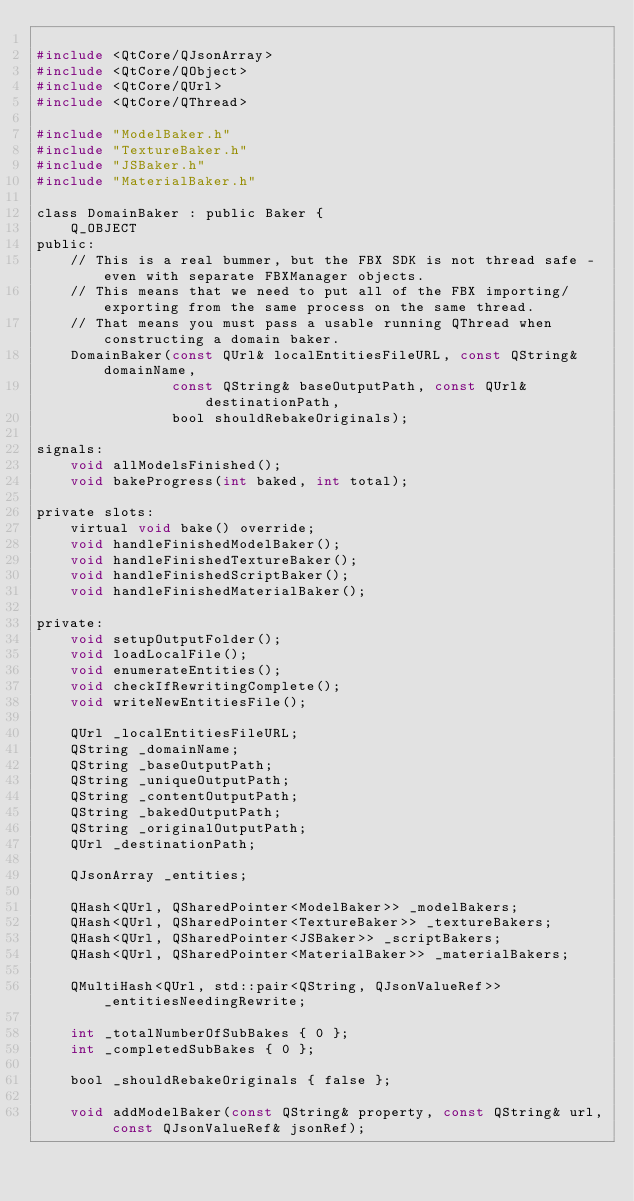<code> <loc_0><loc_0><loc_500><loc_500><_C_>
#include <QtCore/QJsonArray>
#include <QtCore/QObject>
#include <QtCore/QUrl>
#include <QtCore/QThread>

#include "ModelBaker.h"
#include "TextureBaker.h"
#include "JSBaker.h"
#include "MaterialBaker.h"

class DomainBaker : public Baker {
    Q_OBJECT
public:
    // This is a real bummer, but the FBX SDK is not thread safe - even with separate FBXManager objects.
    // This means that we need to put all of the FBX importing/exporting from the same process on the same thread.
    // That means you must pass a usable running QThread when constructing a domain baker.
    DomainBaker(const QUrl& localEntitiesFileURL, const QString& domainName,
                const QString& baseOutputPath, const QUrl& destinationPath,
                bool shouldRebakeOriginals);

signals:
    void allModelsFinished();
    void bakeProgress(int baked, int total);

private slots:
    virtual void bake() override;
    void handleFinishedModelBaker();
    void handleFinishedTextureBaker();
    void handleFinishedScriptBaker();
    void handleFinishedMaterialBaker();

private:
    void setupOutputFolder();
    void loadLocalFile();
    void enumerateEntities();
    void checkIfRewritingComplete();
    void writeNewEntitiesFile();

    QUrl _localEntitiesFileURL;
    QString _domainName;
    QString _baseOutputPath;
    QString _uniqueOutputPath;
    QString _contentOutputPath;
    QString _bakedOutputPath;
    QString _originalOutputPath;
    QUrl _destinationPath;

    QJsonArray _entities;

    QHash<QUrl, QSharedPointer<ModelBaker>> _modelBakers;
    QHash<QUrl, QSharedPointer<TextureBaker>> _textureBakers;
    QHash<QUrl, QSharedPointer<JSBaker>> _scriptBakers;
    QHash<QUrl, QSharedPointer<MaterialBaker>> _materialBakers;
    
    QMultiHash<QUrl, std::pair<QString, QJsonValueRef>> _entitiesNeedingRewrite;

    int _totalNumberOfSubBakes { 0 };
    int _completedSubBakes { 0 };

    bool _shouldRebakeOriginals { false };

    void addModelBaker(const QString& property, const QString& url, const QJsonValueRef& jsonRef);</code> 